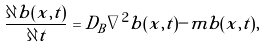<formula> <loc_0><loc_0><loc_500><loc_500>\frac { \partial b ( x , t ) } { \partial t } = { D _ { B } \nabla ^ { 2 } b ( x , t ) - m b ( x , t ) } ,</formula> 